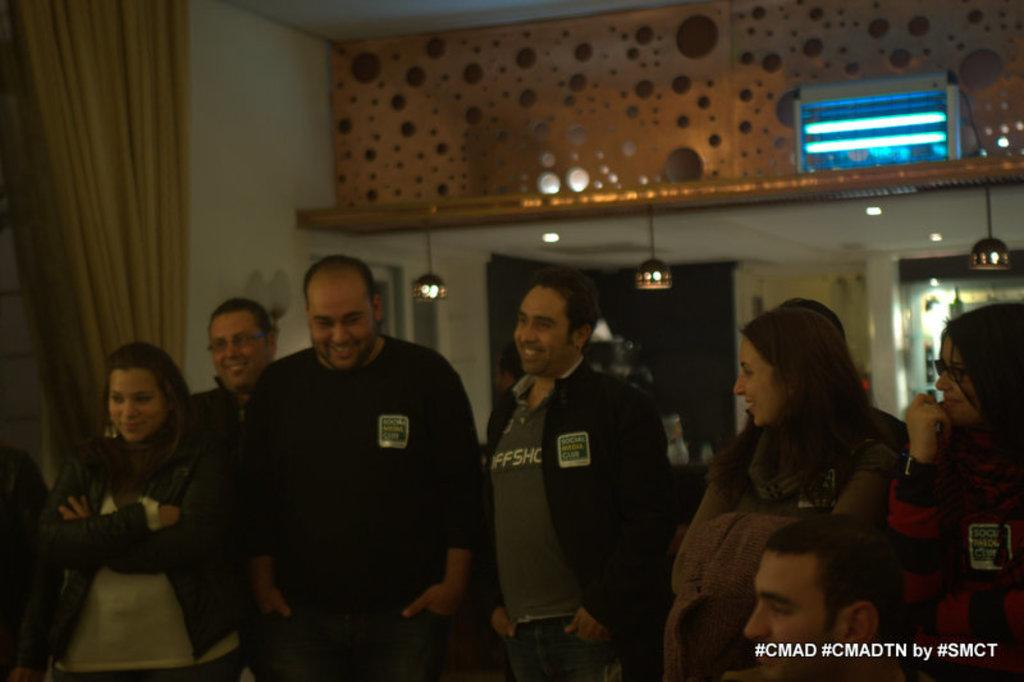What are the people in the image doing? The people are standing on the floor and watching something. Can you describe the curtain in the image? The curtain is on the left side of the image and is near a wall. What is visible above the people in the image? The ceiling is visible in the image, and it has lights on it. What is the caption of the volleyball game in the image? There is no volleyball game or caption present in the image. 